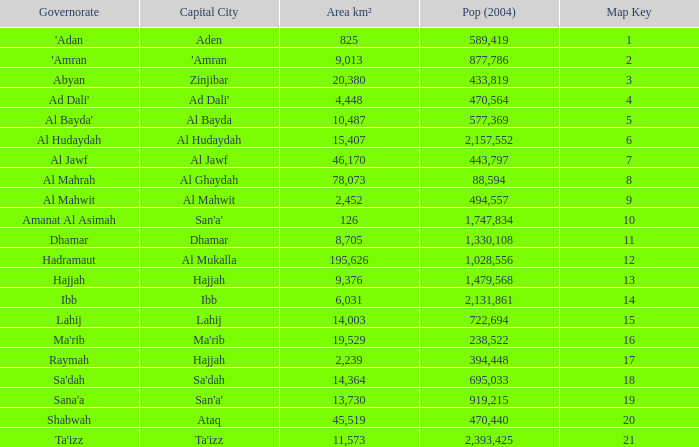What is the count of map keys with an area larger than 14,003 km², al mukalla as their capital city, and a 2004 population greater than 1,028, None. 